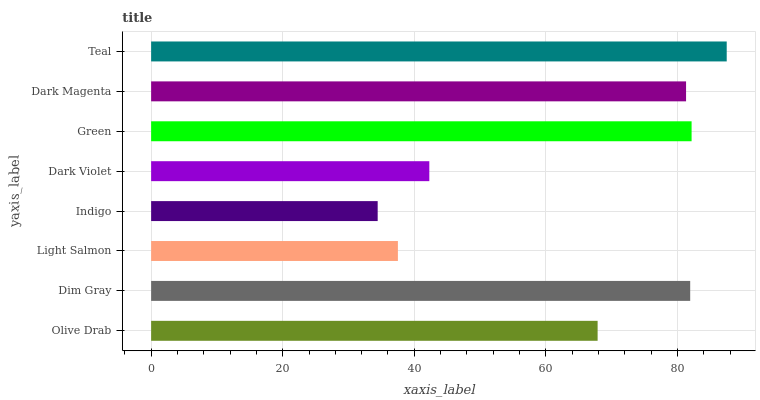Is Indigo the minimum?
Answer yes or no. Yes. Is Teal the maximum?
Answer yes or no. Yes. Is Dim Gray the minimum?
Answer yes or no. No. Is Dim Gray the maximum?
Answer yes or no. No. Is Dim Gray greater than Olive Drab?
Answer yes or no. Yes. Is Olive Drab less than Dim Gray?
Answer yes or no. Yes. Is Olive Drab greater than Dim Gray?
Answer yes or no. No. Is Dim Gray less than Olive Drab?
Answer yes or no. No. Is Dark Magenta the high median?
Answer yes or no. Yes. Is Olive Drab the low median?
Answer yes or no. Yes. Is Green the high median?
Answer yes or no. No. Is Teal the low median?
Answer yes or no. No. 